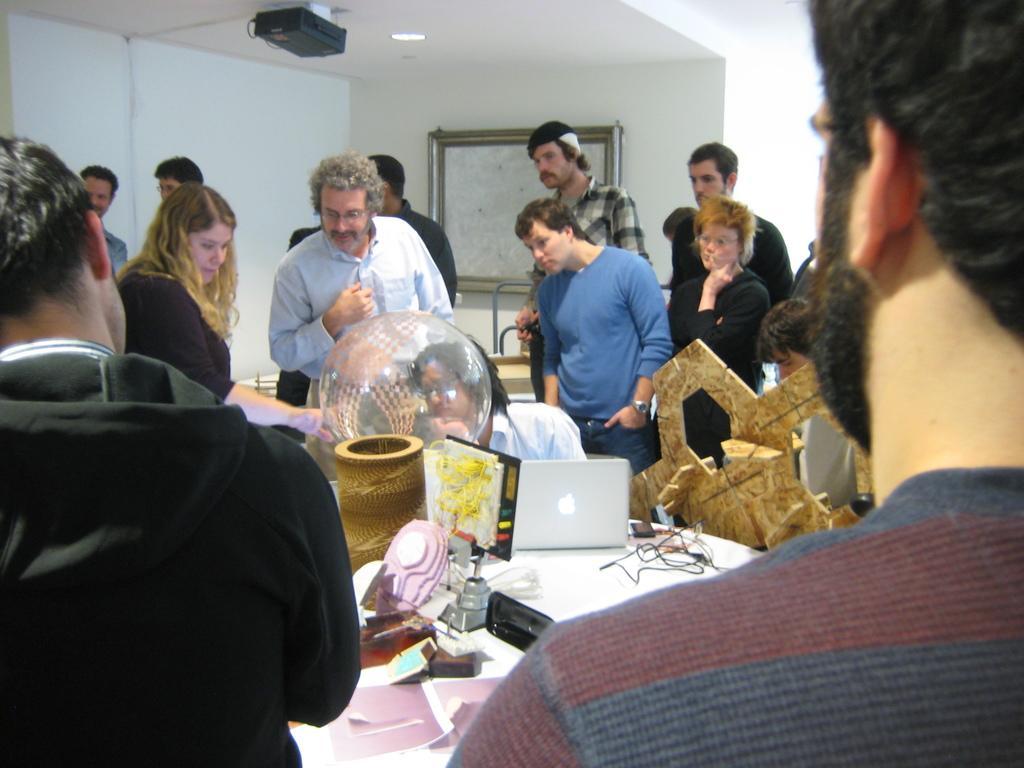Could you give a brief overview of what you see in this image? This is an inside view of a room. Here I can see a table on which a laptop, papers, wires, devices and some other objects are placed. Around the table many people are standing and looking at the object which is placed on the table. In the background there is a wall on which a board is attached. At the top there is a projector and a light. 